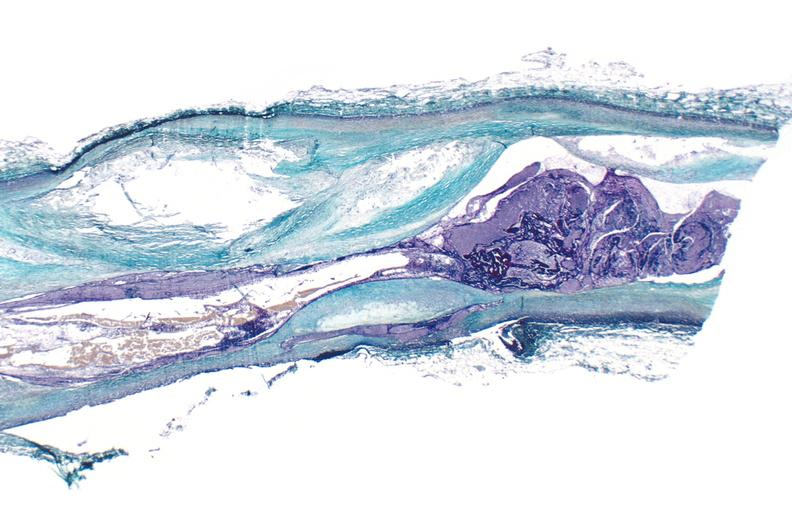what does this image show?
Answer the question using a single word or phrase. Coronary artery atherosclerosis 